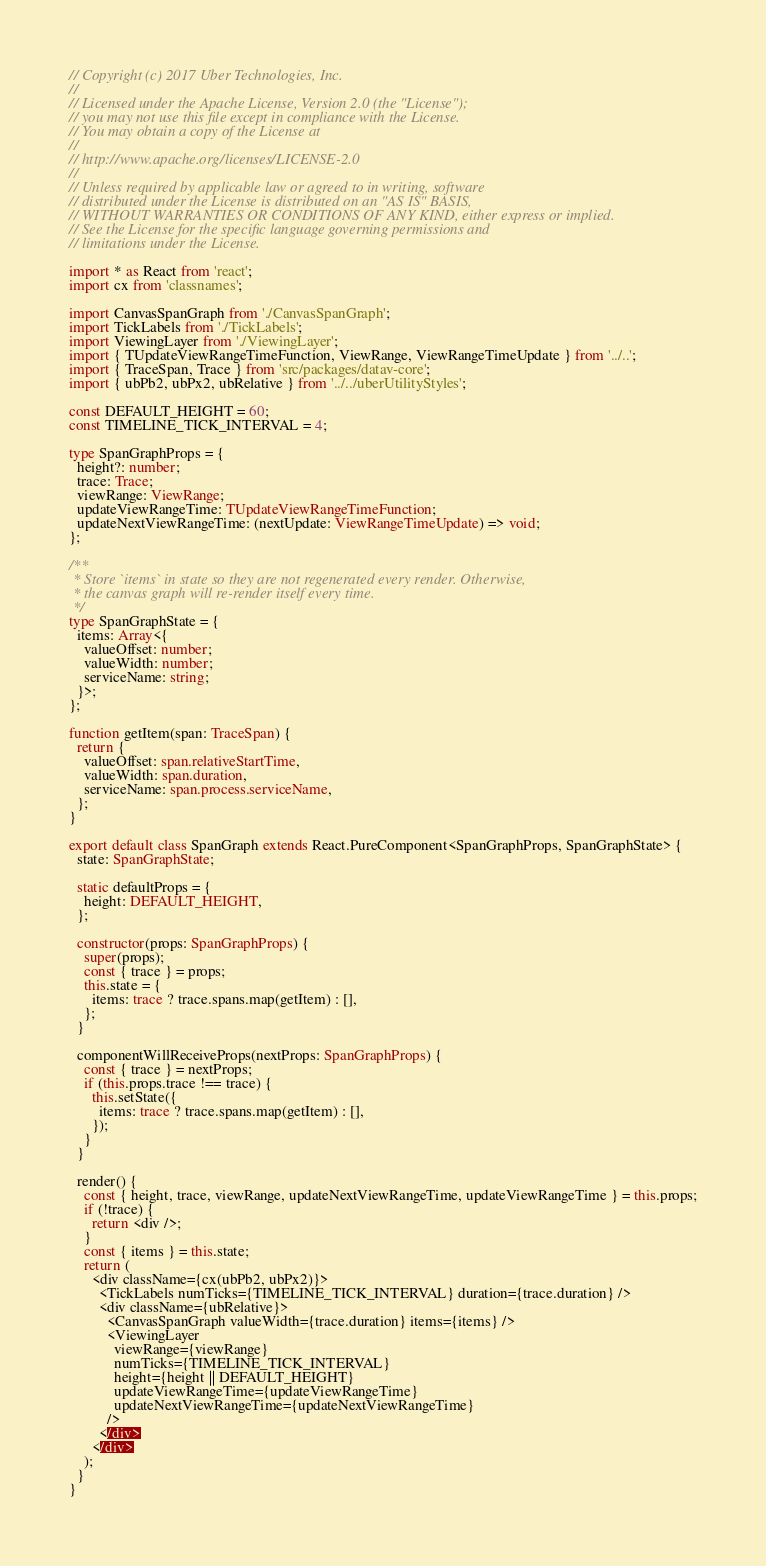Convert code to text. <code><loc_0><loc_0><loc_500><loc_500><_TypeScript_>// Copyright (c) 2017 Uber Technologies, Inc.
//
// Licensed under the Apache License, Version 2.0 (the "License");
// you may not use this file except in compliance with the License.
// You may obtain a copy of the License at
//
// http://www.apache.org/licenses/LICENSE-2.0
//
// Unless required by applicable law or agreed to in writing, software
// distributed under the License is distributed on an "AS IS" BASIS,
// WITHOUT WARRANTIES OR CONDITIONS OF ANY KIND, either express or implied.
// See the License for the specific language governing permissions and
// limitations under the License.

import * as React from 'react';
import cx from 'classnames';

import CanvasSpanGraph from './CanvasSpanGraph';
import TickLabels from './TickLabels';
import ViewingLayer from './ViewingLayer';
import { TUpdateViewRangeTimeFunction, ViewRange, ViewRangeTimeUpdate } from '../..';
import { TraceSpan, Trace } from 'src/packages/datav-core';
import { ubPb2, ubPx2, ubRelative } from '../../uberUtilityStyles';

const DEFAULT_HEIGHT = 60;
const TIMELINE_TICK_INTERVAL = 4;

type SpanGraphProps = {
  height?: number;
  trace: Trace;
  viewRange: ViewRange;
  updateViewRangeTime: TUpdateViewRangeTimeFunction;
  updateNextViewRangeTime: (nextUpdate: ViewRangeTimeUpdate) => void;
};

/**
 * Store `items` in state so they are not regenerated every render. Otherwise,
 * the canvas graph will re-render itself every time.
 */
type SpanGraphState = {
  items: Array<{
    valueOffset: number;
    valueWidth: number;
    serviceName: string;
  }>;
};

function getItem(span: TraceSpan) {
  return {
    valueOffset: span.relativeStartTime,
    valueWidth: span.duration,
    serviceName: span.process.serviceName,
  };
}

export default class SpanGraph extends React.PureComponent<SpanGraphProps, SpanGraphState> {
  state: SpanGraphState;

  static defaultProps = {
    height: DEFAULT_HEIGHT,
  };

  constructor(props: SpanGraphProps) {
    super(props);
    const { trace } = props;
    this.state = {
      items: trace ? trace.spans.map(getItem) : [],
    };
  }

  componentWillReceiveProps(nextProps: SpanGraphProps) {
    const { trace } = nextProps;
    if (this.props.trace !== trace) {
      this.setState({
        items: trace ? trace.spans.map(getItem) : [],
      });
    }
  }

  render() {
    const { height, trace, viewRange, updateNextViewRangeTime, updateViewRangeTime } = this.props;
    if (!trace) {
      return <div />;
    }
    const { items } = this.state;
    return (
      <div className={cx(ubPb2, ubPx2)}>
        <TickLabels numTicks={TIMELINE_TICK_INTERVAL} duration={trace.duration} />
        <div className={ubRelative}>
          <CanvasSpanGraph valueWidth={trace.duration} items={items} />
          <ViewingLayer
            viewRange={viewRange}
            numTicks={TIMELINE_TICK_INTERVAL}
            height={height || DEFAULT_HEIGHT}
            updateViewRangeTime={updateViewRangeTime}
            updateNextViewRangeTime={updateNextViewRangeTime}
          />
        </div>
      </div>
    );
  }
}
</code> 